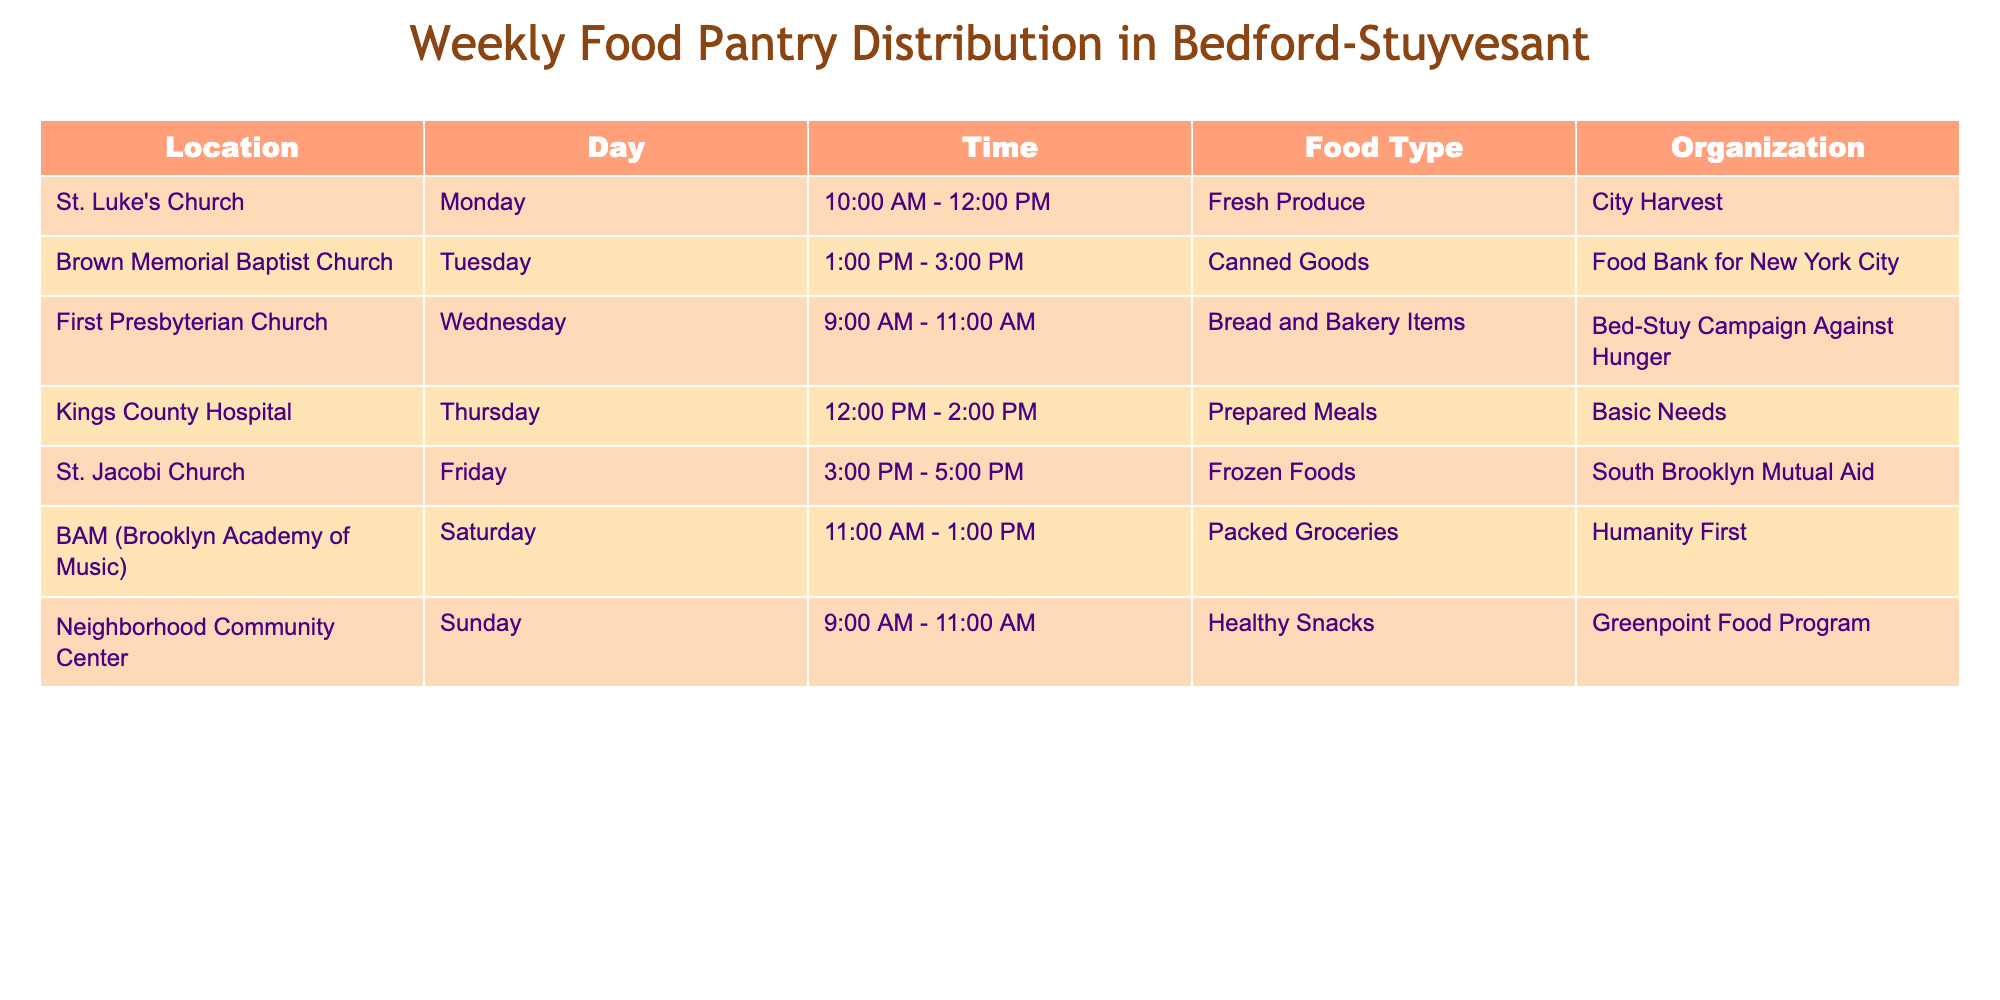What day is the food pantry at St. Luke's Church? The table shows that St. Luke's Church distributes food on Monday.
Answer: Monday Which organization provides canned goods? According to the table, the Food Bank for New York City provides canned goods on Tuesday.
Answer: Food Bank for New York City How many locations distribute food on weekends? The table lists two locations that distribute food on the weekend: BAM on Saturday and Neighborhood Community Center on Sunday.
Answer: 2 What time does food distribution start at Kings County Hospital? The table indicates that food distribution at Kings County Hospital starts at 12:00 PM on Thursday.
Answer: 12:00 PM What type of food does First Presbyterian Church distribute? The table states that First Presbyterian Church distributes Bread and Bakery Items on Wednesday.
Answer: Bread and Bakery Items Is frozen food distributed on a Saturday? The table indicates that frozen foods are not distributed on Saturday; they are distributed on Friday.
Answer: No Which day has the earliest food pantry opening time? By looking at the opening times, First Presbyterian Church opens at 9:00 AM on Wednesday, which is earlier than the other locations.
Answer: Wednesday What is the total number of different food types provided by these pantries? The table lists seven different food types: Fresh Produce, Canned Goods, Bread and Bakery Items, Prepared Meals, Frozen Foods, Packed Groceries, and Healthy Snacks. That sums up to a total of seven different types.
Answer: 7 Which pantry provides prepared meals? The table shows that Basic Needs provides prepared meals at Kings County Hospital on Thursday.
Answer: Basic Needs On what day and time can you get healthy snacks? The table indicates that healthy snacks are available on Sunday from 9:00 AM to 11:00 AM at the Neighborhood Community Center.
Answer: Sunday 9:00 AM - 11:00 AM 